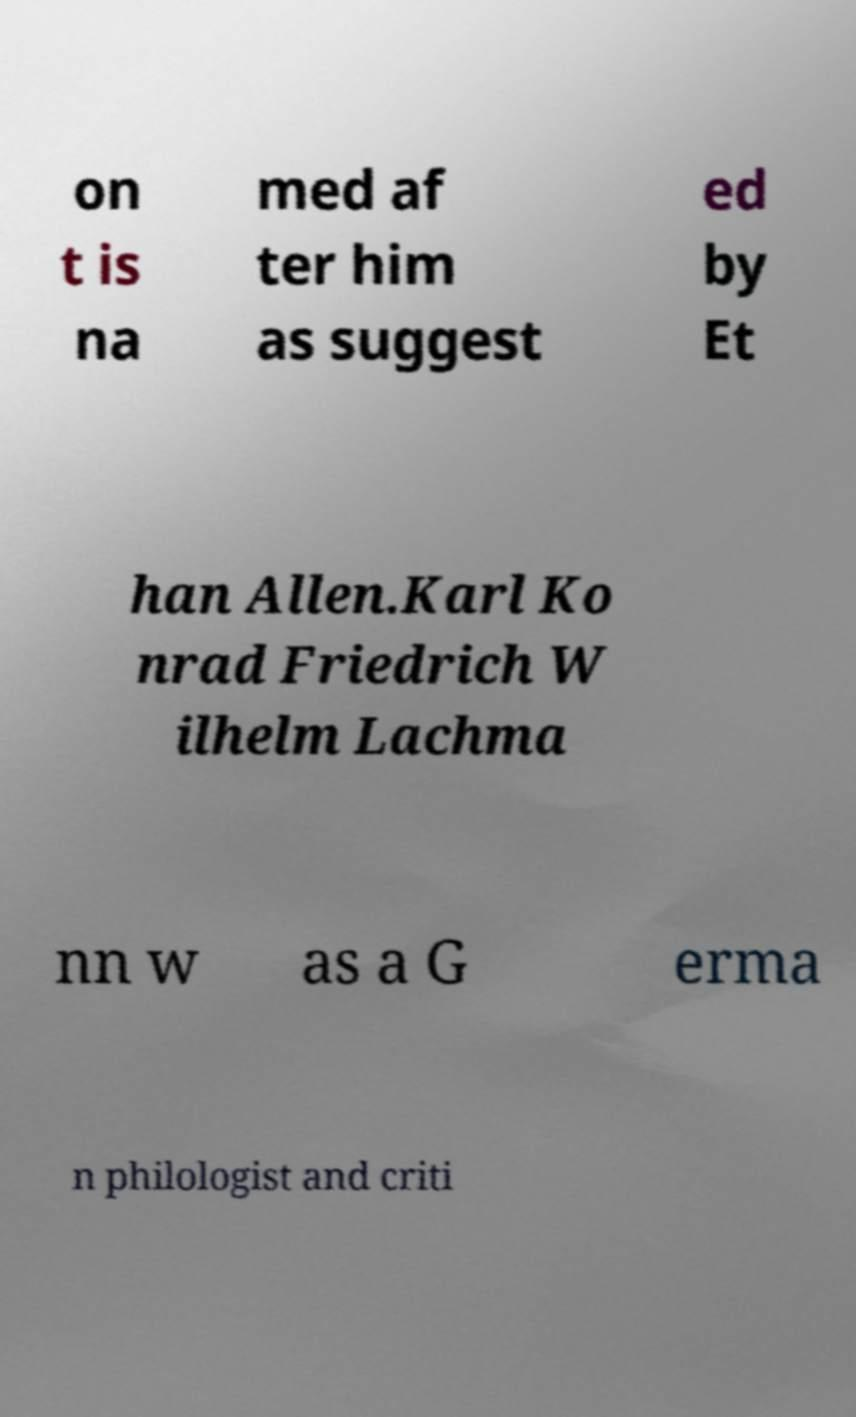Please identify and transcribe the text found in this image. on t is na med af ter him as suggest ed by Et han Allen.Karl Ko nrad Friedrich W ilhelm Lachma nn w as a G erma n philologist and criti 